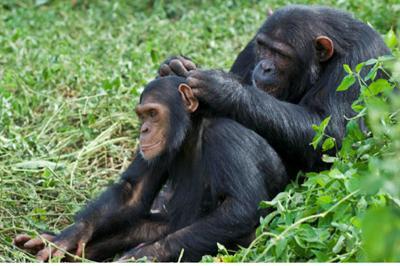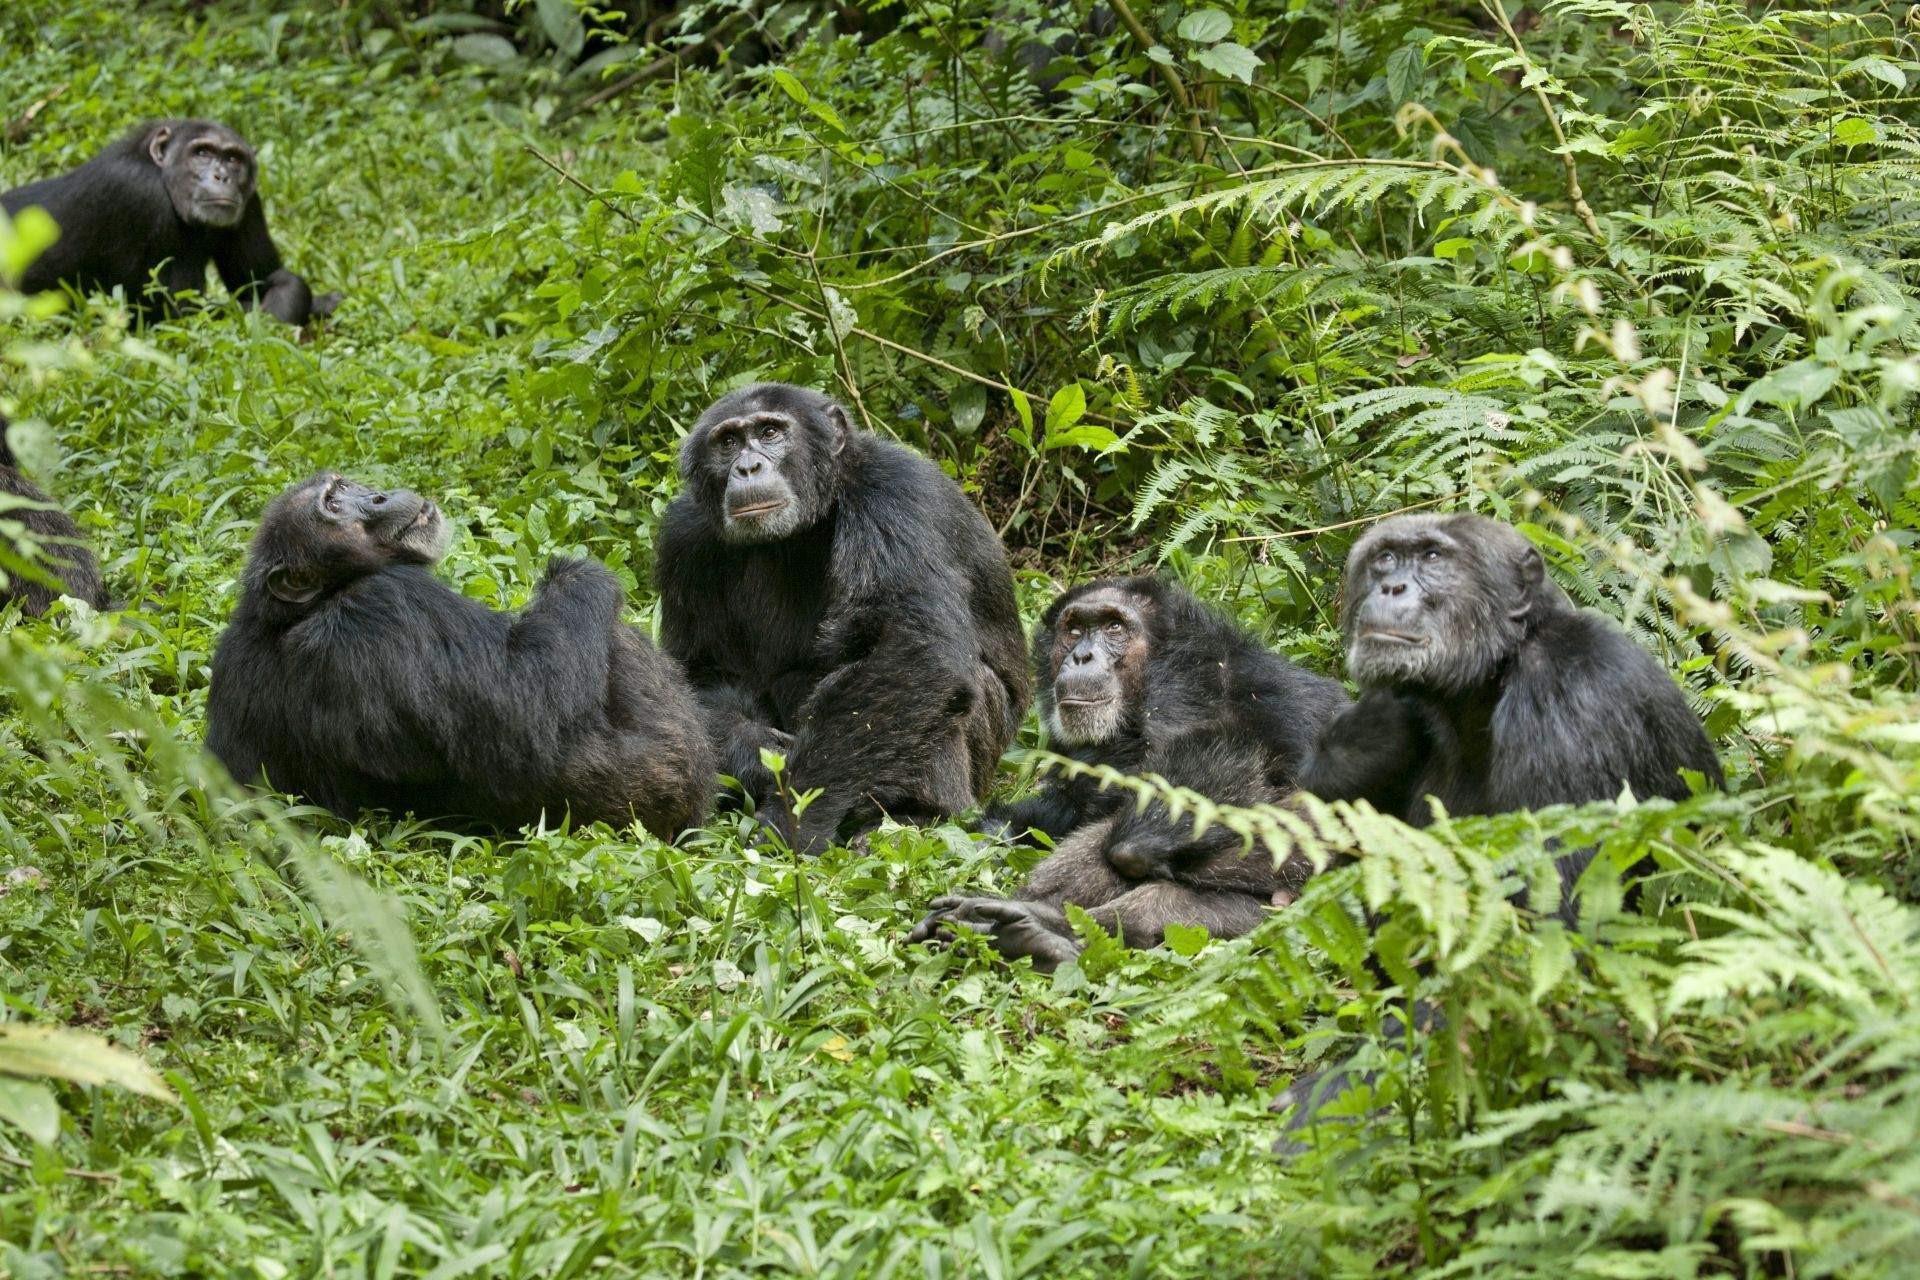The first image is the image on the left, the second image is the image on the right. Assess this claim about the two images: "There are three apes in total.". Correct or not? Answer yes or no. No. 